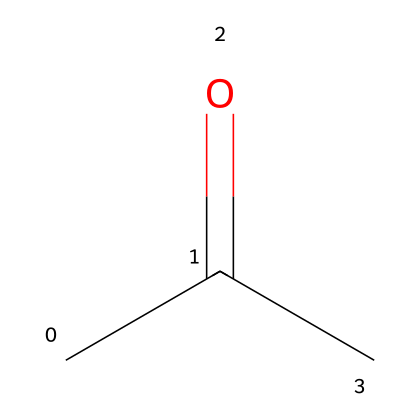What is the molecular formula of acetone? To determine the molecular formula from the SMILES notation (CC(=O)C), we analyze the atoms present. "C" represents carbon atoms, and "O" represents oxygen. There are three carbon atoms and one oxygen atom in the structure. Thus, the molecular formula can be written as C3H6O.
Answer: C3H6O How many carbon atoms are in acetone? The SMILES representation (CC(=O)C) shows three "C" characters, indicating three carbon atoms.
Answer: 3 What type of functional group is present in acetone? The "=O" part indicates a carbonyl group (C=O), which is characteristic of ketones. Since the carbonyl group is located between two carbon atoms, acetone is classified as a ketone.
Answer: ketone What is the total number of hydrogen atoms in acetone? From the molecular formula previously determined (C3H6O), we see that there are six "H" atoms present.
Answer: 6 Is acetone a polar or non-polar molecule? The presence of the carbonyl group (C=O) creates a dipole moment, making acetone polar overall, as the oxygen atom is more electronegative than the surrounding carbon atoms.
Answer: polar What type of ketone is acetone specifically classified as? Acetone is classified as a simple ketone, as it contains only one carbonyl group and is the simplest member of the ketone family.
Answer: simple ketone 